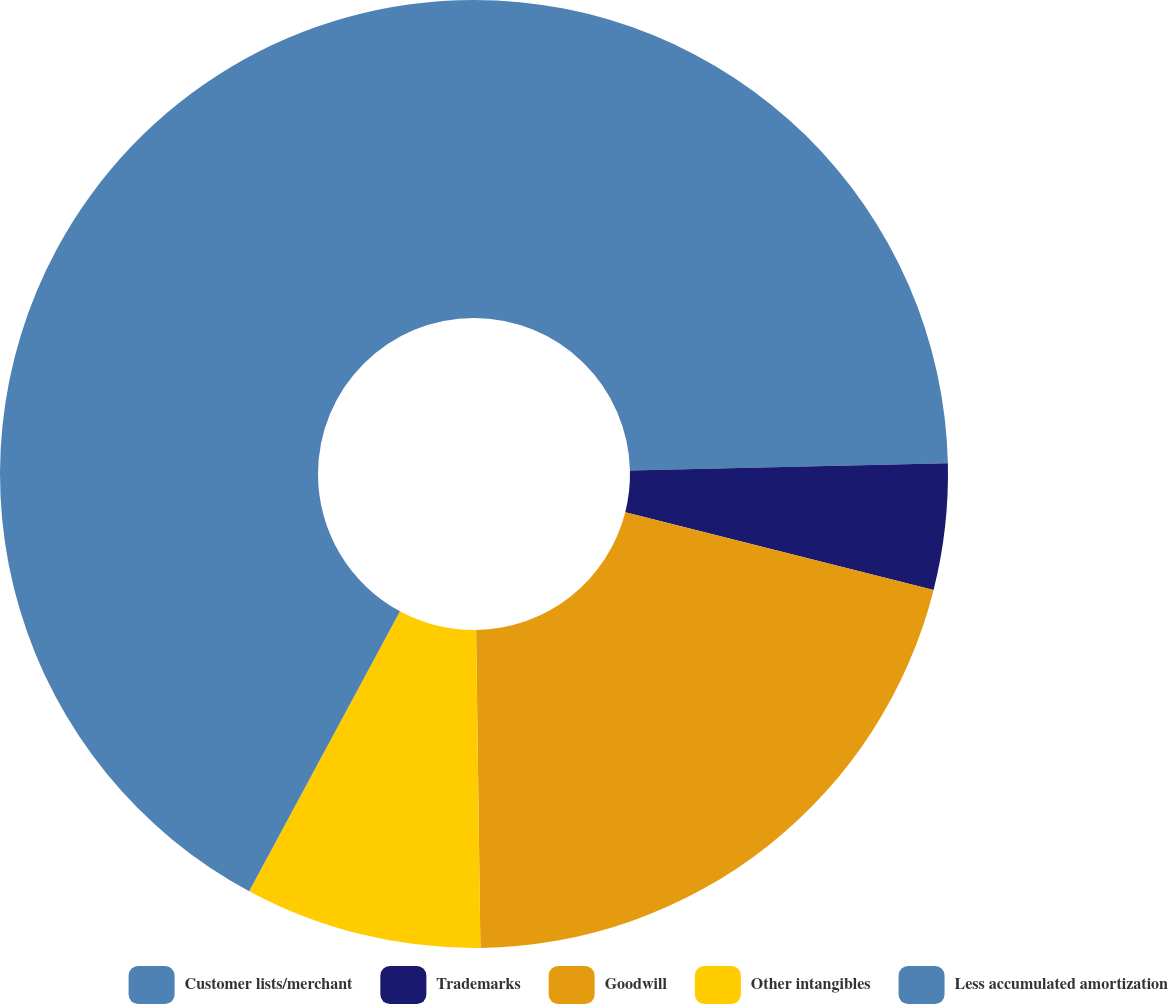Convert chart. <chart><loc_0><loc_0><loc_500><loc_500><pie_chart><fcel>Customer lists/merchant<fcel>Trademarks<fcel>Goodwill<fcel>Other intangibles<fcel>Less accumulated amortization<nl><fcel>24.64%<fcel>4.29%<fcel>20.85%<fcel>8.08%<fcel>42.13%<nl></chart> 